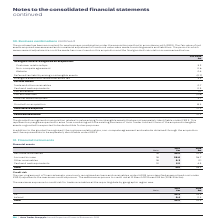According to Auto Trader's financial document, What were the total financial assets in 2019? According to the financial document, 59.1 (in millions). The relevant text states: "Total 59.1 56.5..." Also, In which years was the amount of total financial assets calculated? The document shows two values: 2019 and 2018. From the document: "Note 2019 £m 2018 £m Note 2019 £m 2018 £m..." Also, What were the components making up the total financial assets in the table? The document contains multiple relevant values: Net trade receivables, Accrued income, Other receivables, Cash and cash equivalents. From the document: "Net trade receivables 18 24.9 25.4 Other receivables 18 0.3 0.1 Accrued income 18 28.0 26.7 Cash and cash equivalents 19 5.9 4.3..." Additionally, In which year was the amount of Other receivables larger? According to the financial document, 2019. The relevant text states: "Note 2019 £m 2018 £m..." Also, can you calculate: What was the change in Other receivables in 2019 from 2018? Based on the calculation: 0.3-0.1, the result is 0.2 (in millions). This is based on the information: "Other receivables 18 0.3 0.1 Other receivables 18 0.3 0.1..." The key data points involved are: 0.1, 0.3. Also, can you calculate: What was the percentage change in Other receivables in 2019 from 2018? To answer this question, I need to perform calculations using the financial data. The calculation is: (0.3-0.1)/0.1, which equals 200 (percentage). This is based on the information: "Other receivables 18 0.3 0.1 Other receivables 18 0.3 0.1..." The key data points involved are: 0.1, 0.3. 